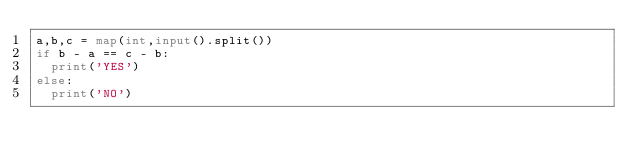Convert code to text. <code><loc_0><loc_0><loc_500><loc_500><_Python_>a,b,c = map(int,input().split())
if b - a == c - b:
  print('YES')
else:
  print('NO')</code> 